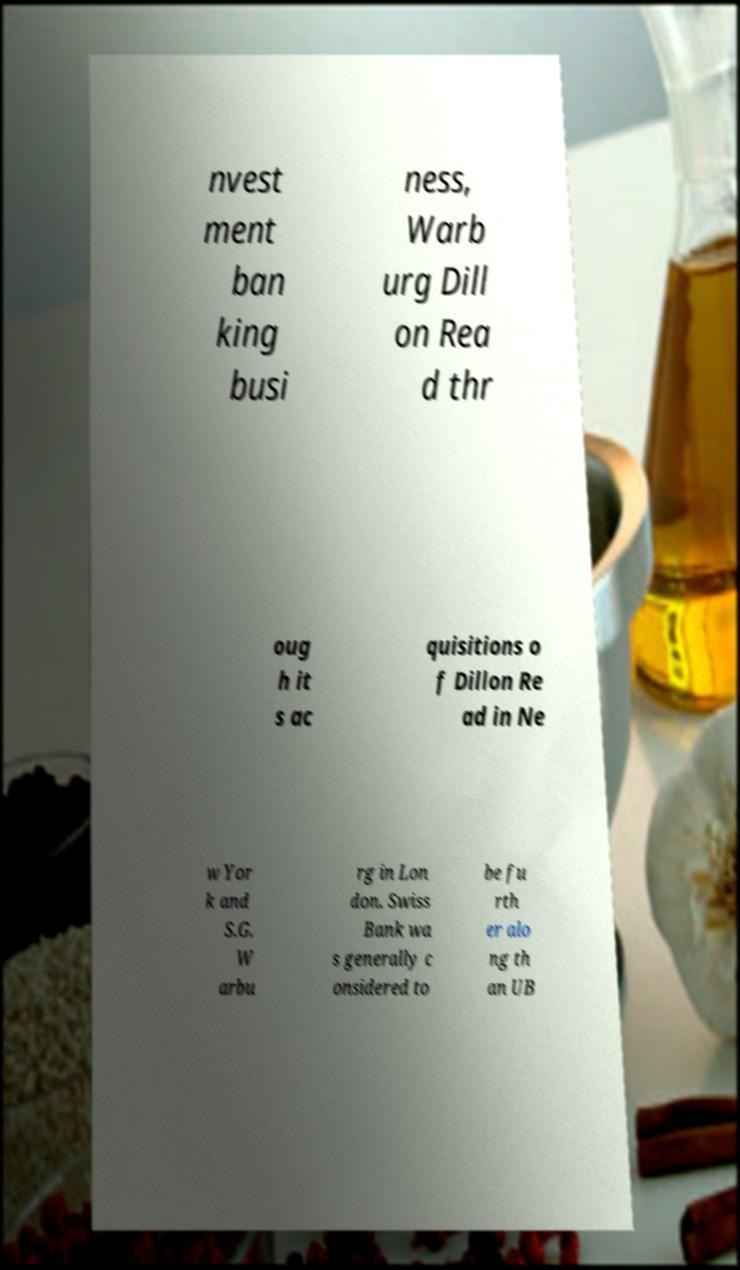Can you accurately transcribe the text from the provided image for me? nvest ment ban king busi ness, Warb urg Dill on Rea d thr oug h it s ac quisitions o f Dillon Re ad in Ne w Yor k and S.G. W arbu rg in Lon don. Swiss Bank wa s generally c onsidered to be fu rth er alo ng th an UB 